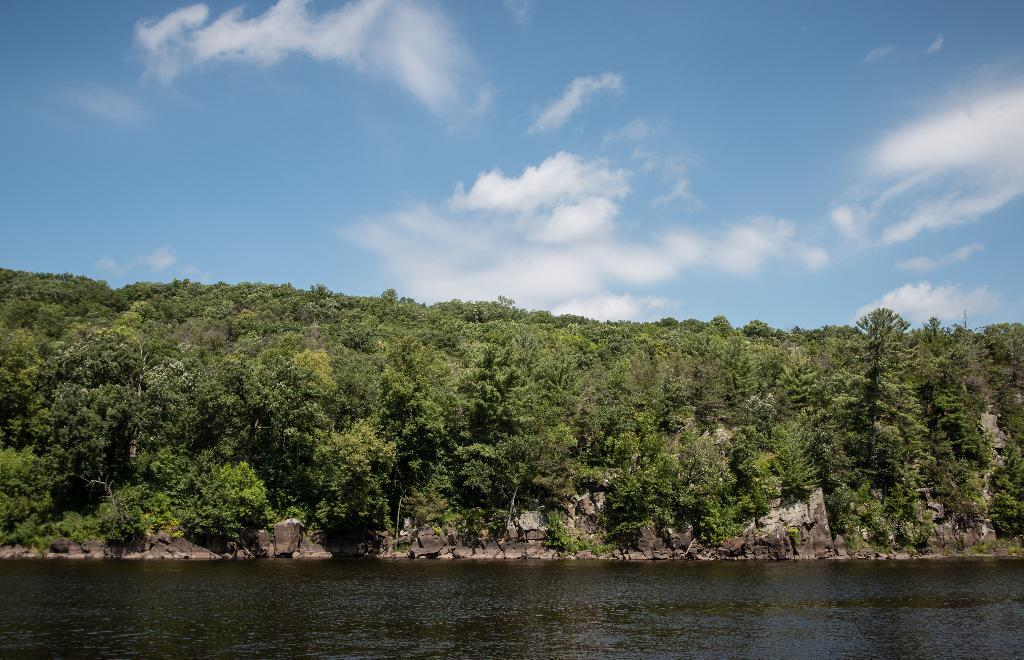What is the primary element visible in the image? There is water in the image. What type of vegetation can be seen in the image? There are trees in the image. What is visible in the background of the image? The sky is visible in the background of the image. What can be observed in the sky? Clouds are present in the sky. What type of comb can be seen in the image? There is no comb present in the image. What type of leather material is visible in the image? There is no leather material visible in the image. 